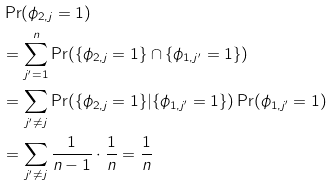Convert formula to latex. <formula><loc_0><loc_0><loc_500><loc_500>& \Pr ( \phi _ { 2 , j } = 1 ) \\ & = \sum _ { j ^ { \prime } = 1 } ^ { n } \Pr ( \{ \phi _ { 2 , j } = 1 \} \cap \{ \phi _ { 1 , j ^ { \prime } } = 1 \} ) \\ & = \sum _ { j ^ { \prime } \neq j } \Pr ( \{ \phi _ { 2 , j } = 1 \} | \{ \phi _ { 1 , j ^ { \prime } } = 1 \} ) \Pr ( \phi _ { 1 , j ^ { \prime } } = 1 ) \\ & = \sum _ { j ^ { \prime } \neq j } \frac { 1 } { n - 1 } \cdot \frac { 1 } { n } = \frac { 1 } { n }</formula> 